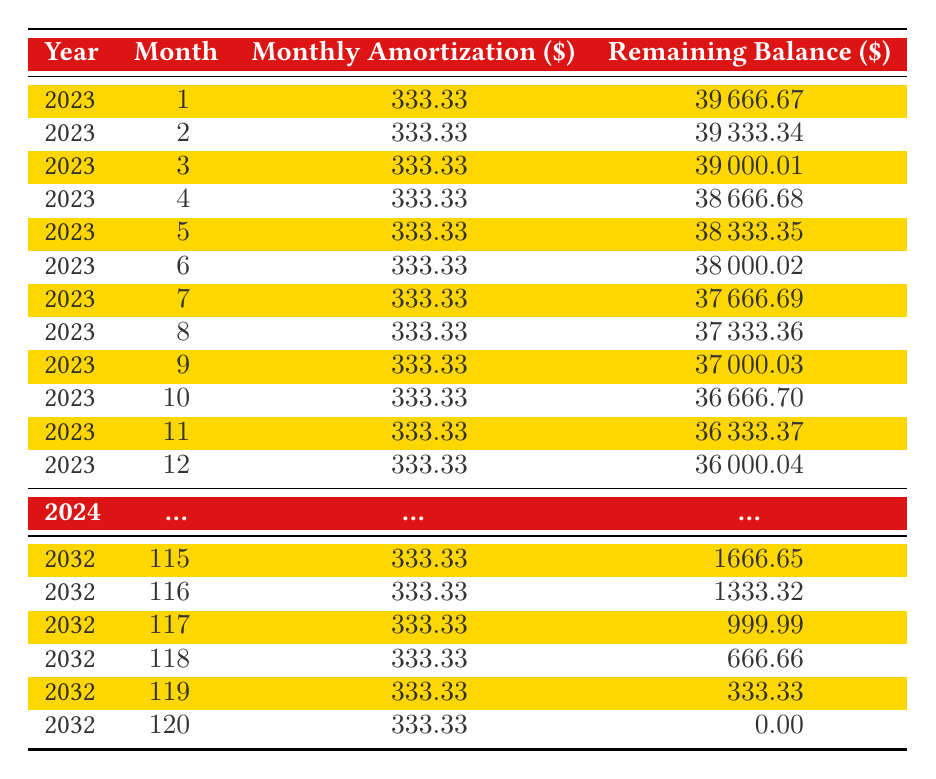What is the monthly amortization amount for the restoration costs? The monthly amortization is listed directly in the table under the "Monthly Amortization ($)" column for each month, which shows a consistent value of 333.33.
Answer: 333.33 How much is the remaining balance after the first month? To find the remaining balance after the first month, we look at the first entry in the "Remaining Balance ($)" column, which is 39666.67.
Answer: 39666.67 What is the total amortization period in months for the restoration costs? The total amortization period is provided in the "totalMonths" field, which states that it is 120 months.
Answer: 120 Is the remaining balance ever negative during the amortization period? No, the remaining balance decreases each month but never goes below zero, as the final balance in the last month is shown to be 0.00.
Answer: No What is the remaining balance after six months of amortization? We look at the sixth row of the table to find the remaining balance after six months, which is 38000.02.
Answer: 38000.02 What is the sum of the remaining balances after the first three months? We sum the remaining balances from the first three months: 39666.67 + 39333.34 + 39000.01 = 118000.02.
Answer: 118000.02 How much does the remaining balance decrease each month? The remaining balance decreases by the same monthly amortization amount of 333.33 each month.
Answer: 333.33 What would be the remaining balance after 6 months if no amortization occurred? If no amortization occurred, the balance would remain at the total restoration costs of 40000, since no payments would reduce it.
Answer: 40000 In which month will the remaining balance reach zero? The last entry shows that the remaining balance reaches zero in the 120th month.
Answer: 120th month 